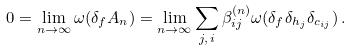<formula> <loc_0><loc_0><loc_500><loc_500>0 = \lim _ { n \to \infty } \omega ( \delta _ { f } A _ { n } ) = \lim _ { n \to \infty } \sum _ { j , \, i } \beta _ { i j } ^ { ( n ) } \omega ( \delta _ { f } \delta _ { h _ { j } } \delta _ { c _ { i j } } ) \, .</formula> 